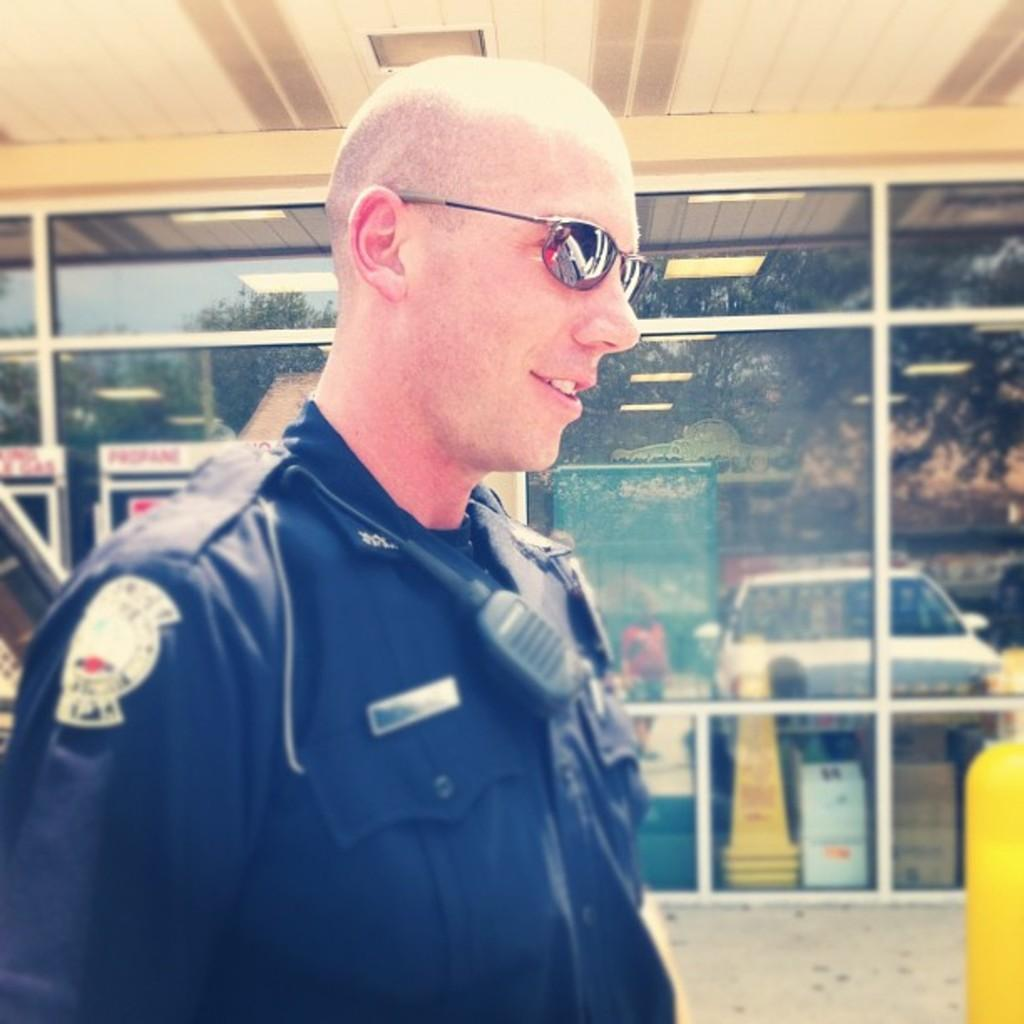What can be seen in the image related to a person? There is a person in the image, and they are wearing goggles. What is the main feature of the background in the image? The main feature of the background is a glass wall. What can be seen in the reflections on the glass wall? The glass wall has reflections of a vehicle, a person, trees, and a building. What type of plants can be seen growing on the person's finger in the image? There are no plants visible on any person's finger in the image. What kind of quartz is present in the image? There is no quartz present in the image. 